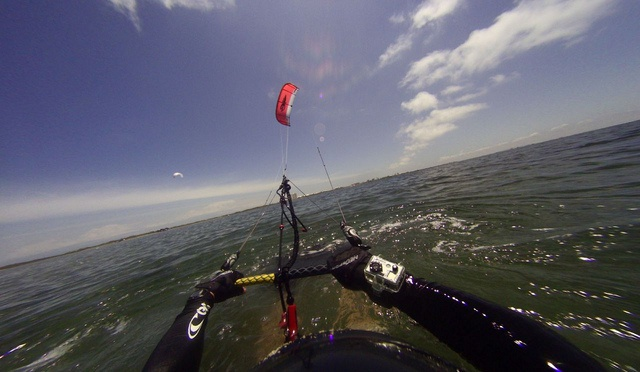Describe the objects in this image and their specific colors. I can see a kite in navy, salmon, maroon, brown, and darkgray tones in this image. 